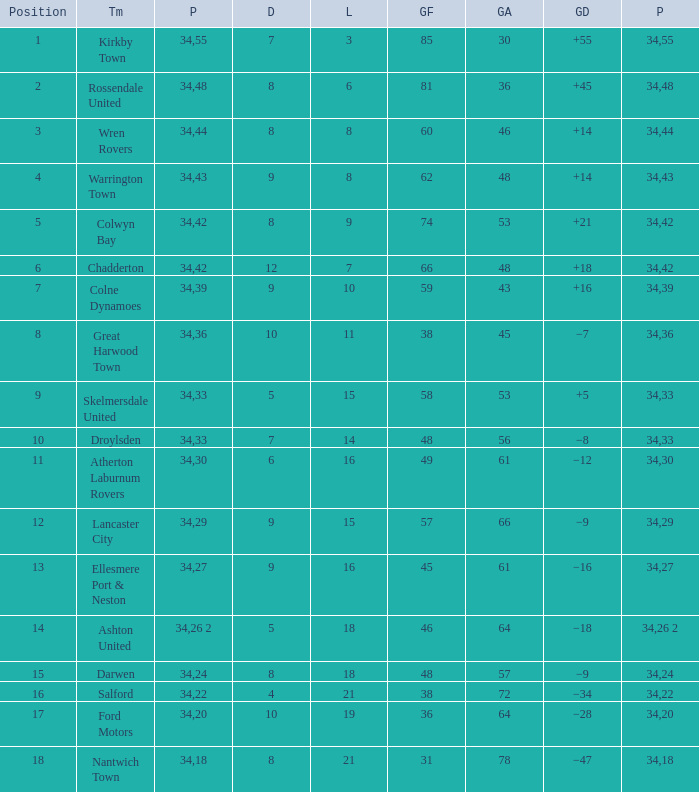What is the smallest number of goals against when there are 1 of 18 points, and more than 8 are drawn? None. 